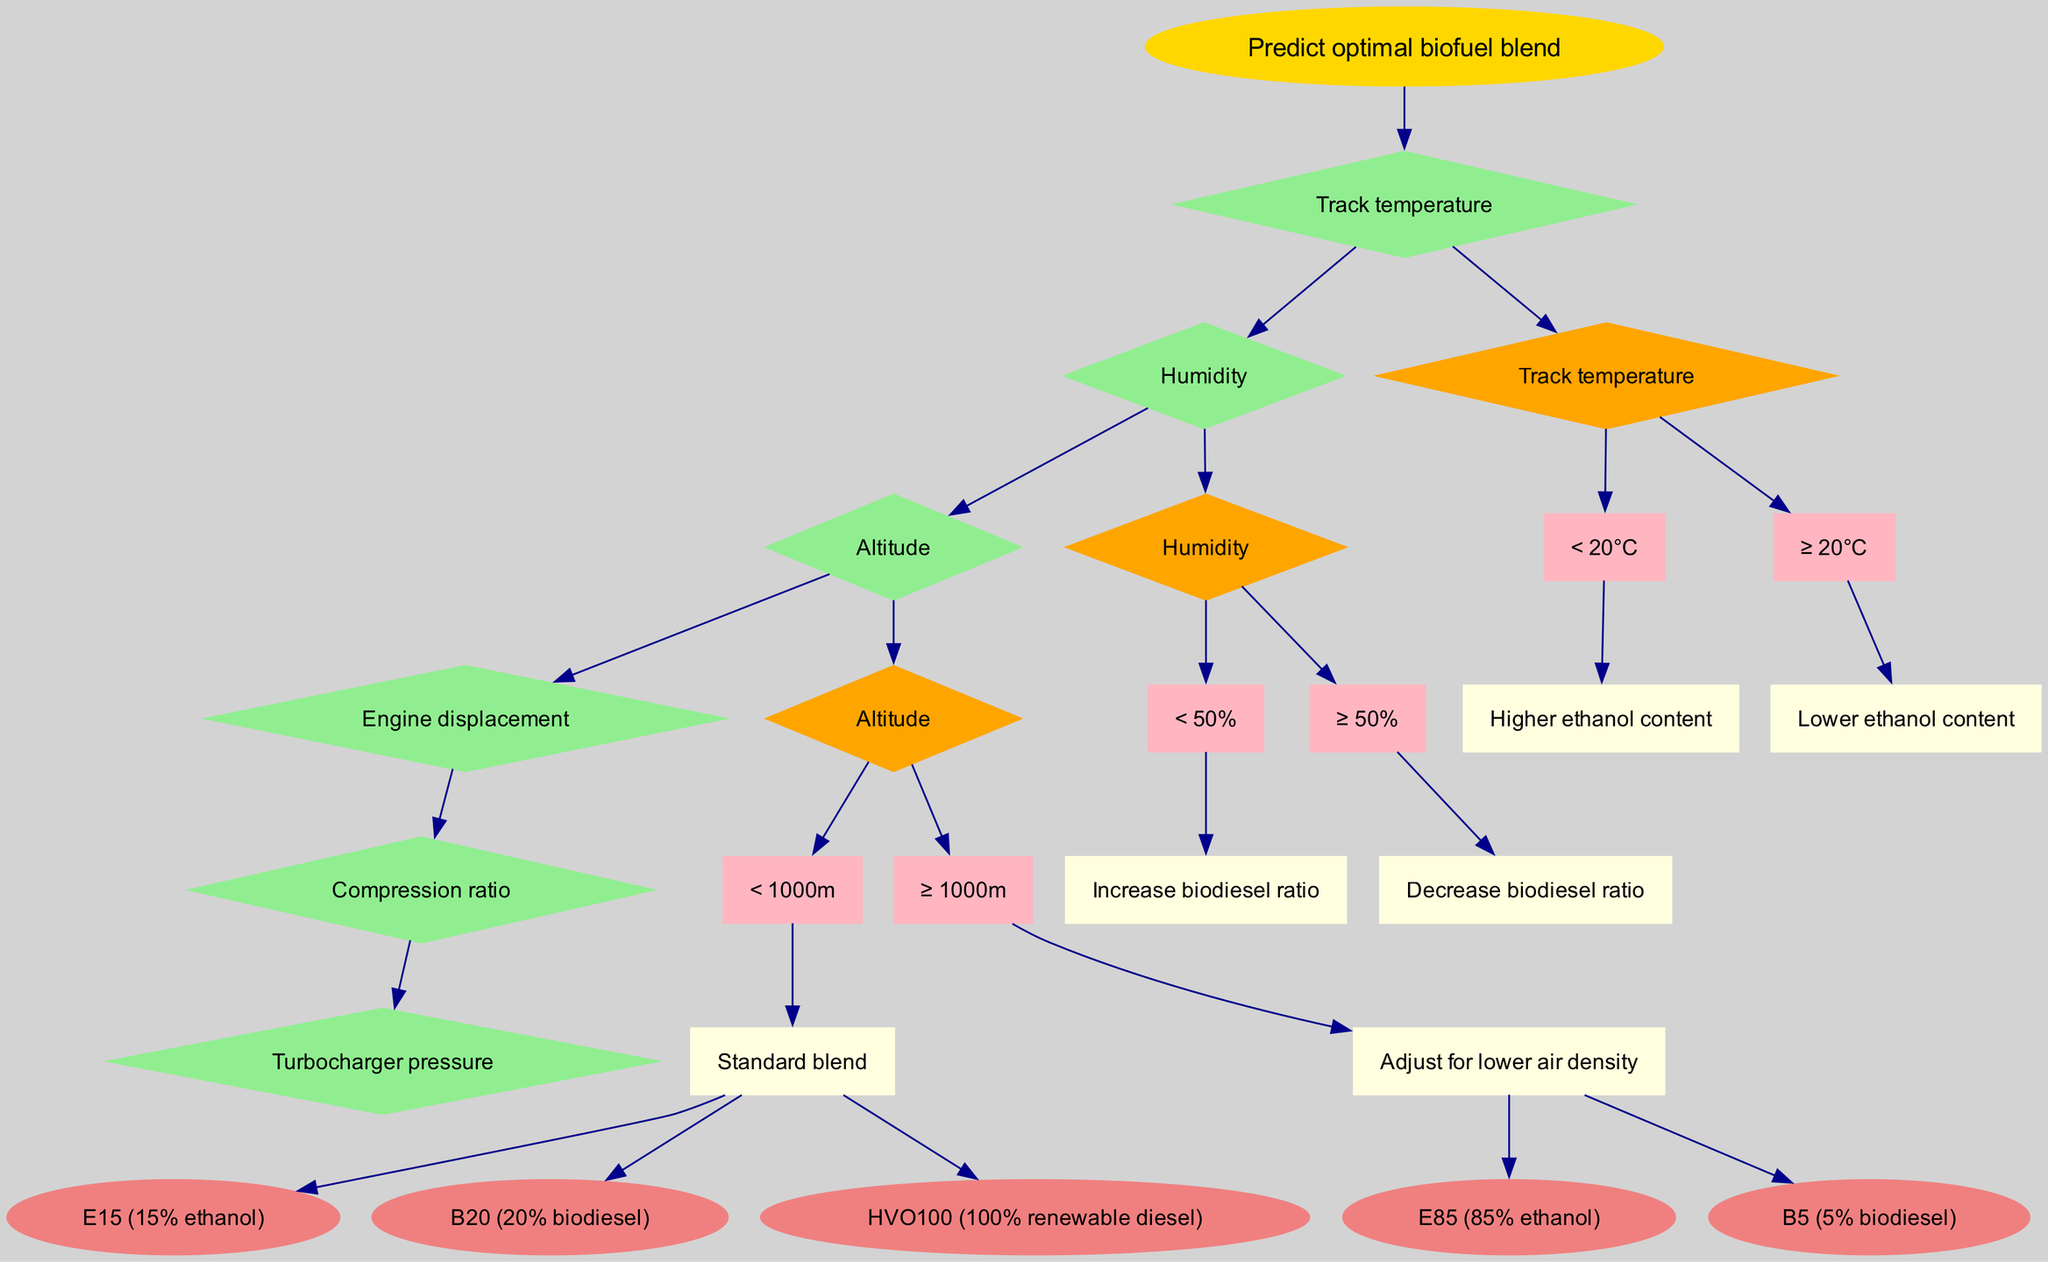What is the root node of the diagram? The diagram's root node states the primary objective, which is to 'Predict optimal biofuel blend.'
Answer: Predict optimal biofuel blend How many features are used in the decision tree? The diagram lists six features that are used to make decisions, allowing comprehensive analysis based on environmental and engine conditions.
Answer: 6 What happens if the humidity is more than or equal to 50%? According to the decision node for humidity, if the condition is met, the action taken is to 'Decrease biodiesel ratio.'
Answer: Decrease biodiesel ratio Which decision node follows the 'Track temperature' node? The diagram indicates that after evaluating track temperature, the next decision node to consider is 'Humidity.' This is part of the flowchart's structure which connects nodes sequentially.
Answer: Humidity What is the condition for adjusting the blend at high altitudes? It specifies that if the altitude is greater than or equal to 1000 meters, the blend must be adjusted for lower air density, indicating a need for modification in the fuel composition at high altitudes.
Answer: Adjust for lower air density How many branches does the 'Humidity' decision node have? The 'Humidity' decision node contains two distinct branches that dictate actions based on whether humidity is below or above the specified threshold.
Answer: 2 What is the outcome if track temperature is less than 20°C? When the track temperature is below 20°C, the tree specifies to use a 'Higher ethanol content,' indicating an optimal blend for colder conditions.
Answer: Higher ethanol content Which outcome is linked to the previous humidity decision node if the humidity is less than 50%? The resulting decision from this humidity evaluation leads to increasing the biodiesel ratio, which might be beneficial in certain environmental conditions.
Answer: Increase biodiesel ratio What color are the outcome nodes represented in the diagram? Each outcome node is depicted in light coral, providing a distinct visual identity among the other nodes in the diagram and emphasizing their role as final results.
Answer: Light coral 